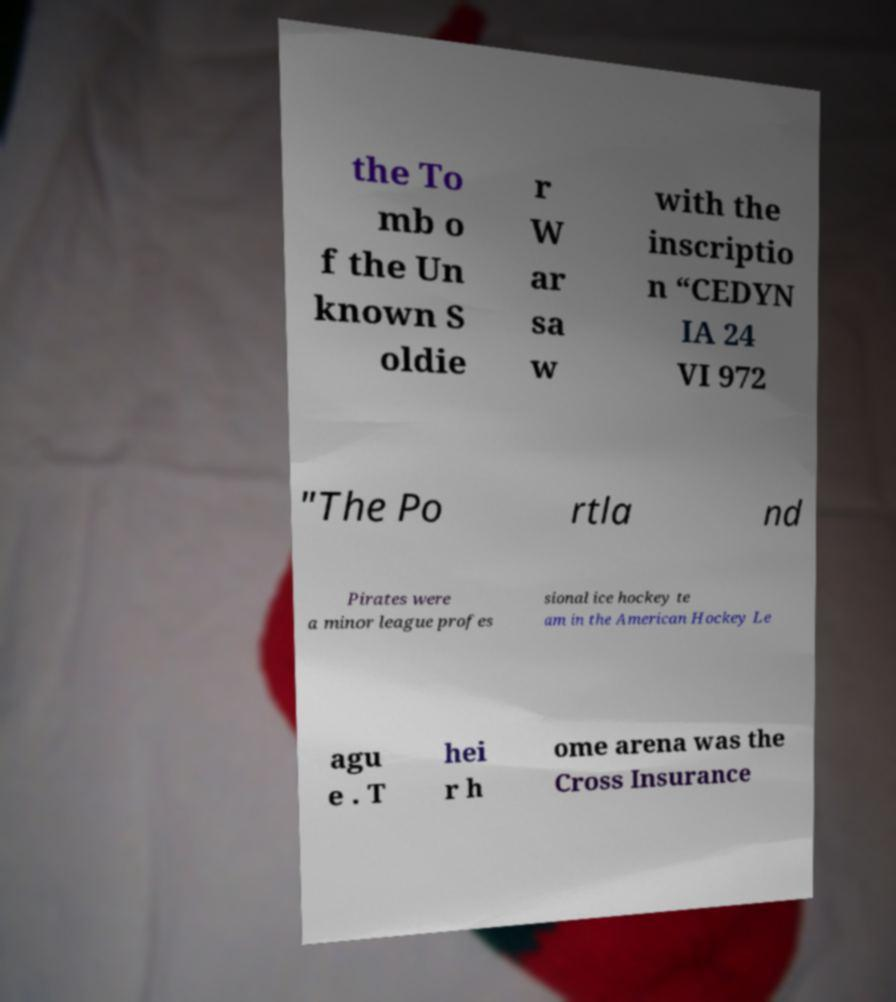Can you accurately transcribe the text from the provided image for me? the To mb o f the Un known S oldie r W ar sa w with the inscriptio n “CEDYN IA 24 VI 972 "The Po rtla nd Pirates were a minor league profes sional ice hockey te am in the American Hockey Le agu e . T hei r h ome arena was the Cross Insurance 